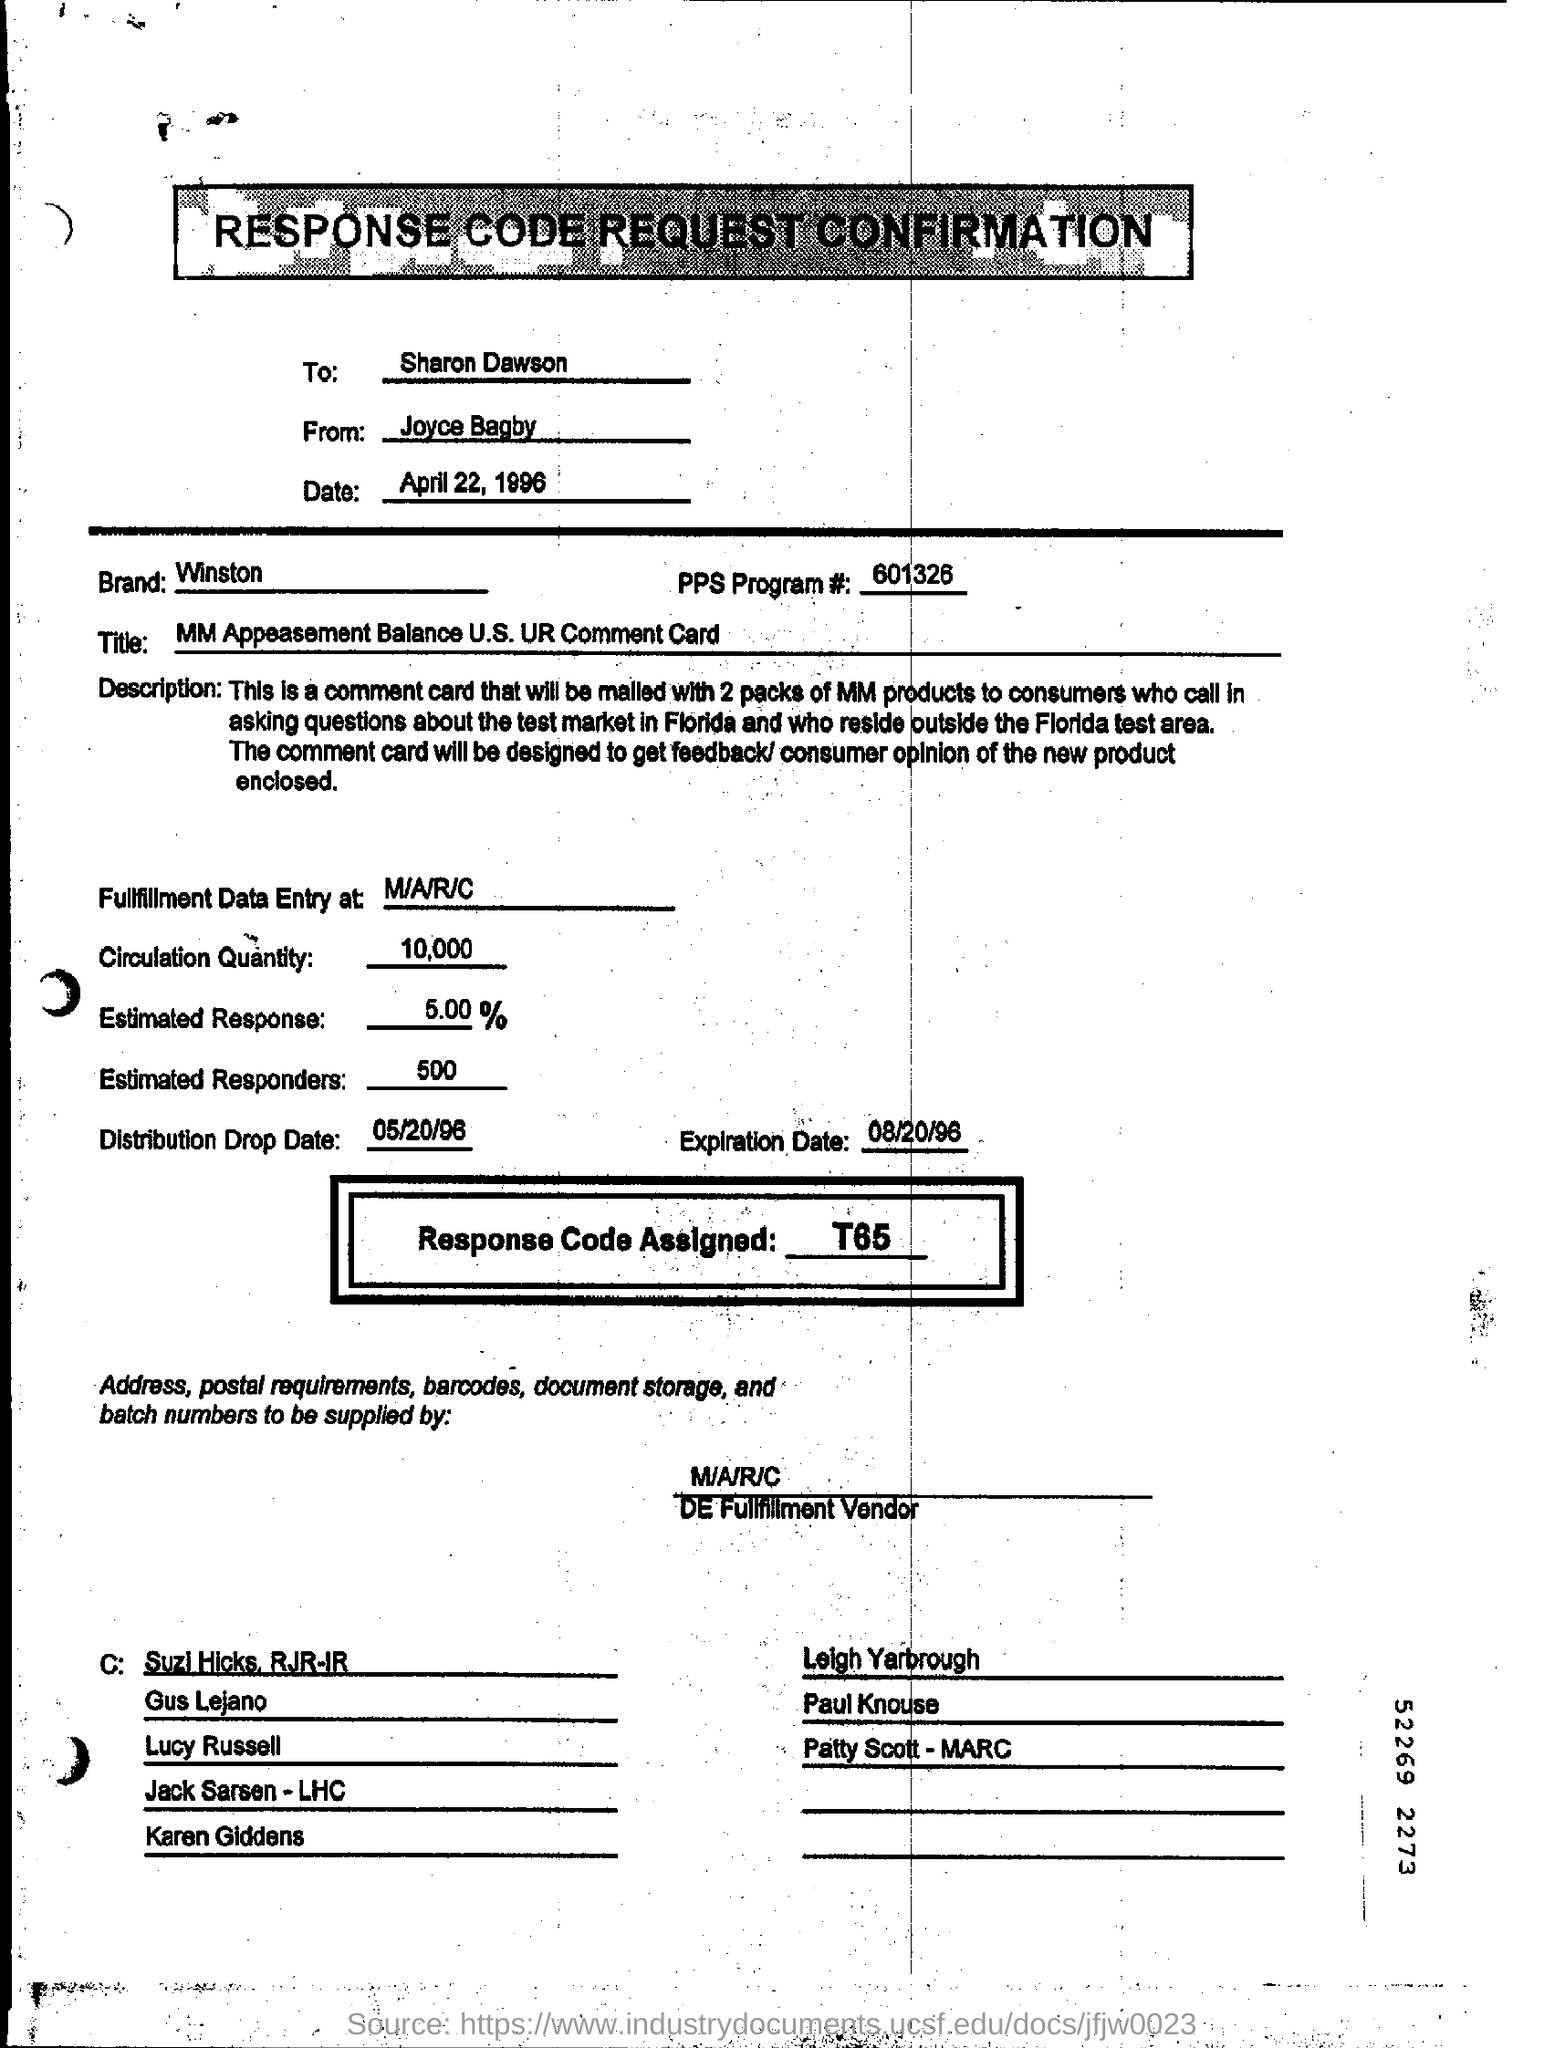Who is it addressed to?
Give a very brief answer. Sharon Dawson. What is the Date?
Keep it short and to the point. April 22, 1996. What is the Brand?
Give a very brief answer. Winston. What is the PPs Program #?
Offer a very short reply. 601326. Where is the fullfillment data entry at?
Offer a terse response. M/A/R/C. What is the Circulation Qty?
Provide a succinct answer. 10,000. What is the response code assigned?
Your answer should be compact. T65. What is the distribution drop date?
Provide a short and direct response. 05/20/96. What is the expiration date?
Provide a succinct answer. 08/20/96. 